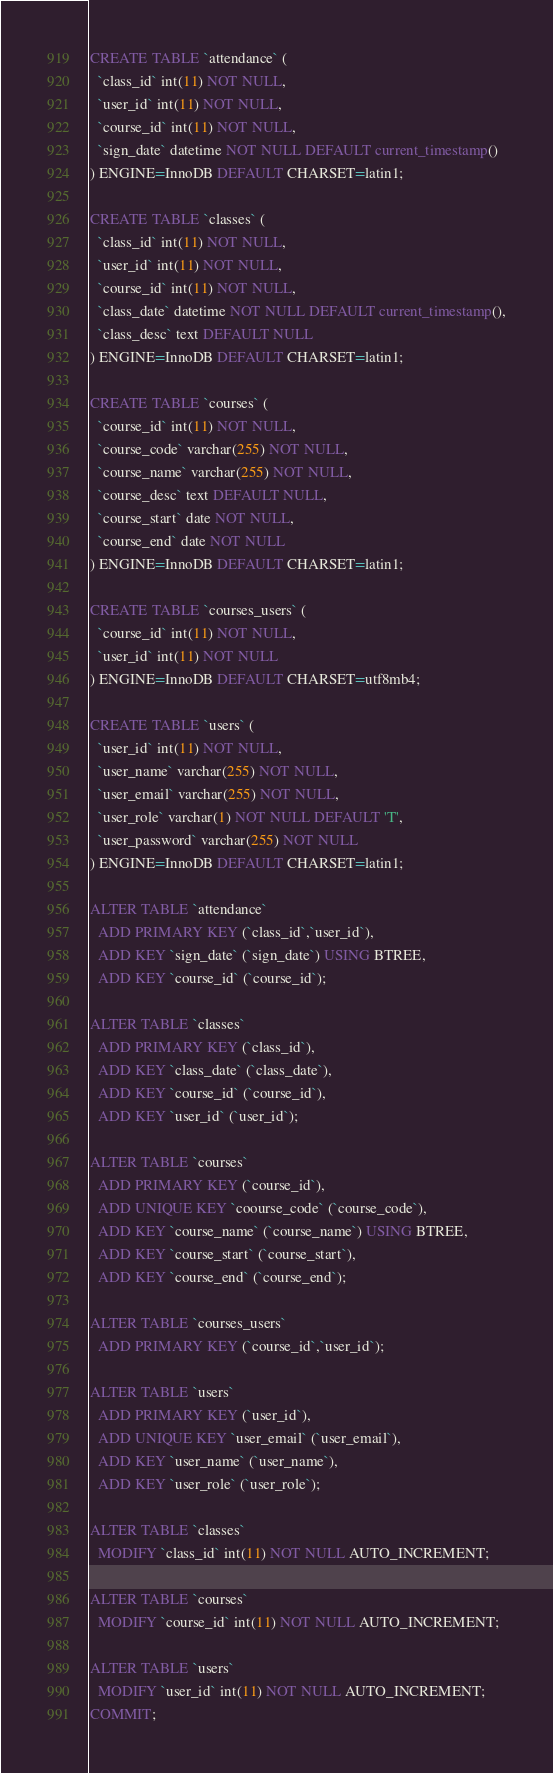Convert code to text. <code><loc_0><loc_0><loc_500><loc_500><_SQL_>CREATE TABLE `attendance` (
  `class_id` int(11) NOT NULL,
  `user_id` int(11) NOT NULL,
  `course_id` int(11) NOT NULL,
  `sign_date` datetime NOT NULL DEFAULT current_timestamp()
) ENGINE=InnoDB DEFAULT CHARSET=latin1;

CREATE TABLE `classes` (
  `class_id` int(11) NOT NULL,
  `user_id` int(11) NOT NULL,
  `course_id` int(11) NOT NULL,
  `class_date` datetime NOT NULL DEFAULT current_timestamp(),
  `class_desc` text DEFAULT NULL
) ENGINE=InnoDB DEFAULT CHARSET=latin1;

CREATE TABLE `courses` (
  `course_id` int(11) NOT NULL,
  `course_code` varchar(255) NOT NULL,
  `course_name` varchar(255) NOT NULL,
  `course_desc` text DEFAULT NULL,
  `course_start` date NOT NULL,
  `course_end` date NOT NULL
) ENGINE=InnoDB DEFAULT CHARSET=latin1;

CREATE TABLE `courses_users` (
  `course_id` int(11) NOT NULL,
  `user_id` int(11) NOT NULL
) ENGINE=InnoDB DEFAULT CHARSET=utf8mb4;

CREATE TABLE `users` (
  `user_id` int(11) NOT NULL,
  `user_name` varchar(255) NOT NULL,
  `user_email` varchar(255) NOT NULL,
  `user_role` varchar(1) NOT NULL DEFAULT 'T',
  `user_password` varchar(255) NOT NULL
) ENGINE=InnoDB DEFAULT CHARSET=latin1;

ALTER TABLE `attendance`
  ADD PRIMARY KEY (`class_id`,`user_id`),
  ADD KEY `sign_date` (`sign_date`) USING BTREE,
  ADD KEY `course_id` (`course_id`);

ALTER TABLE `classes`
  ADD PRIMARY KEY (`class_id`),
  ADD KEY `class_date` (`class_date`),
  ADD KEY `course_id` (`course_id`),
  ADD KEY `user_id` (`user_id`);

ALTER TABLE `courses`
  ADD PRIMARY KEY (`course_id`),
  ADD UNIQUE KEY `coourse_code` (`course_code`),
  ADD KEY `course_name` (`course_name`) USING BTREE,
  ADD KEY `course_start` (`course_start`),
  ADD KEY `course_end` (`course_end`);

ALTER TABLE `courses_users`
  ADD PRIMARY KEY (`course_id`,`user_id`);

ALTER TABLE `users`
  ADD PRIMARY KEY (`user_id`),
  ADD UNIQUE KEY `user_email` (`user_email`),
  ADD KEY `user_name` (`user_name`),
  ADD KEY `user_role` (`user_role`);

ALTER TABLE `classes`
  MODIFY `class_id` int(11) NOT NULL AUTO_INCREMENT;

ALTER TABLE `courses`
  MODIFY `course_id` int(11) NOT NULL AUTO_INCREMENT;

ALTER TABLE `users`
  MODIFY `user_id` int(11) NOT NULL AUTO_INCREMENT;
COMMIT;
</code> 